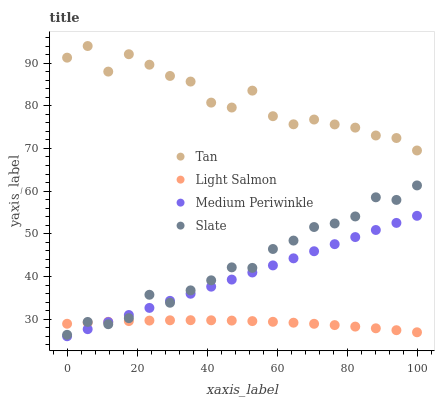Does Light Salmon have the minimum area under the curve?
Answer yes or no. Yes. Does Tan have the maximum area under the curve?
Answer yes or no. Yes. Does Slate have the minimum area under the curve?
Answer yes or no. No. Does Slate have the maximum area under the curve?
Answer yes or no. No. Is Medium Periwinkle the smoothest?
Answer yes or no. Yes. Is Tan the roughest?
Answer yes or no. Yes. Is Slate the smoothest?
Answer yes or no. No. Is Slate the roughest?
Answer yes or no. No. Does Medium Periwinkle have the lowest value?
Answer yes or no. Yes. Does Slate have the lowest value?
Answer yes or no. No. Does Tan have the highest value?
Answer yes or no. Yes. Does Slate have the highest value?
Answer yes or no. No. Is Light Salmon less than Tan?
Answer yes or no. Yes. Is Tan greater than Slate?
Answer yes or no. Yes. Does Slate intersect Light Salmon?
Answer yes or no. Yes. Is Slate less than Light Salmon?
Answer yes or no. No. Is Slate greater than Light Salmon?
Answer yes or no. No. Does Light Salmon intersect Tan?
Answer yes or no. No. 